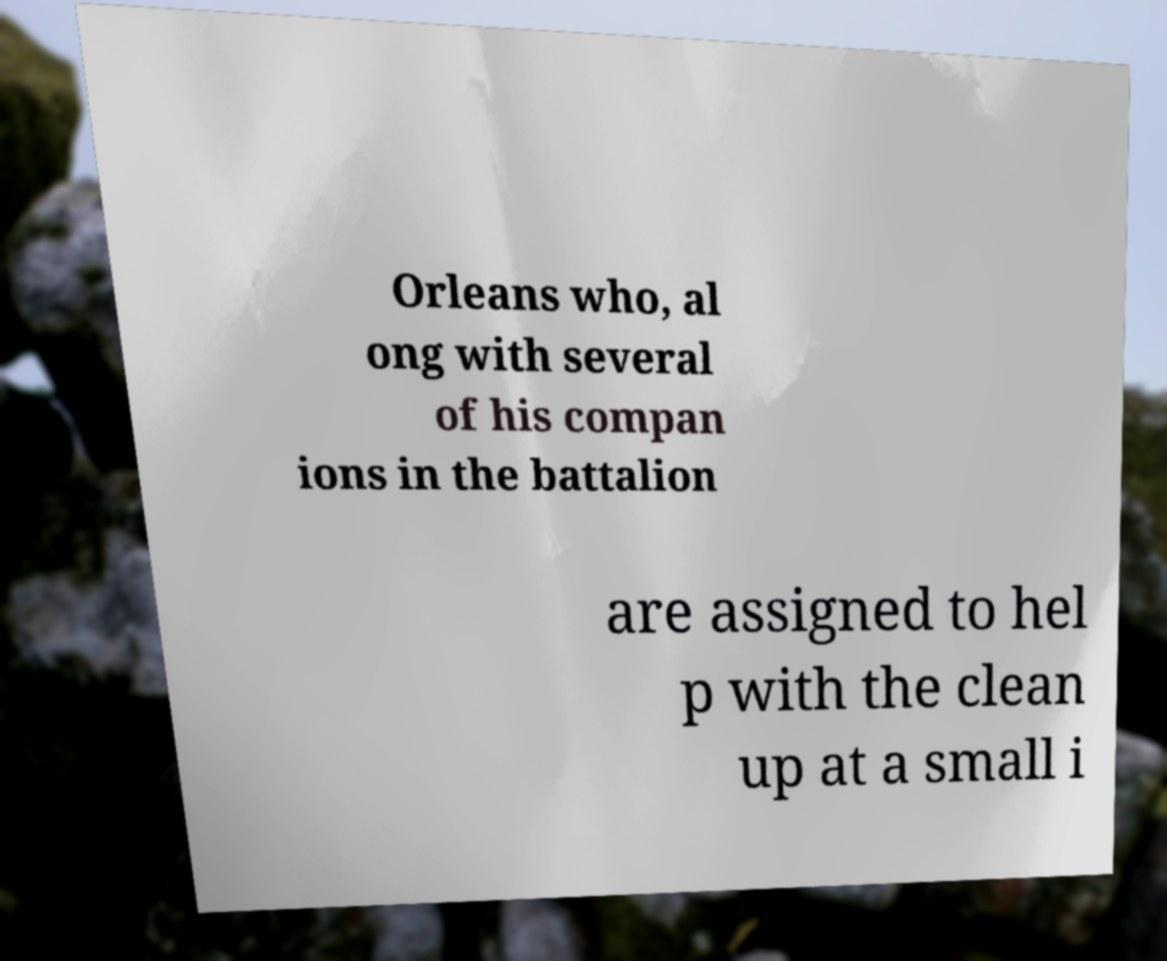What messages or text are displayed in this image? I need them in a readable, typed format. Orleans who, al ong with several of his compan ions in the battalion are assigned to hel p with the clean up at a small i 